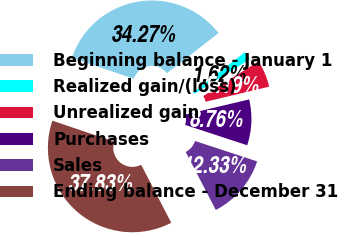Convert chart to OTSL. <chart><loc_0><loc_0><loc_500><loc_500><pie_chart><fcel>Beginning balance - January 1<fcel>Realized gain/(loss)<fcel>Unrealized gain<fcel>Purchases<fcel>Sales<fcel>Ending balance - December 31<nl><fcel>34.27%<fcel>1.62%<fcel>5.19%<fcel>8.76%<fcel>12.33%<fcel>37.83%<nl></chart> 